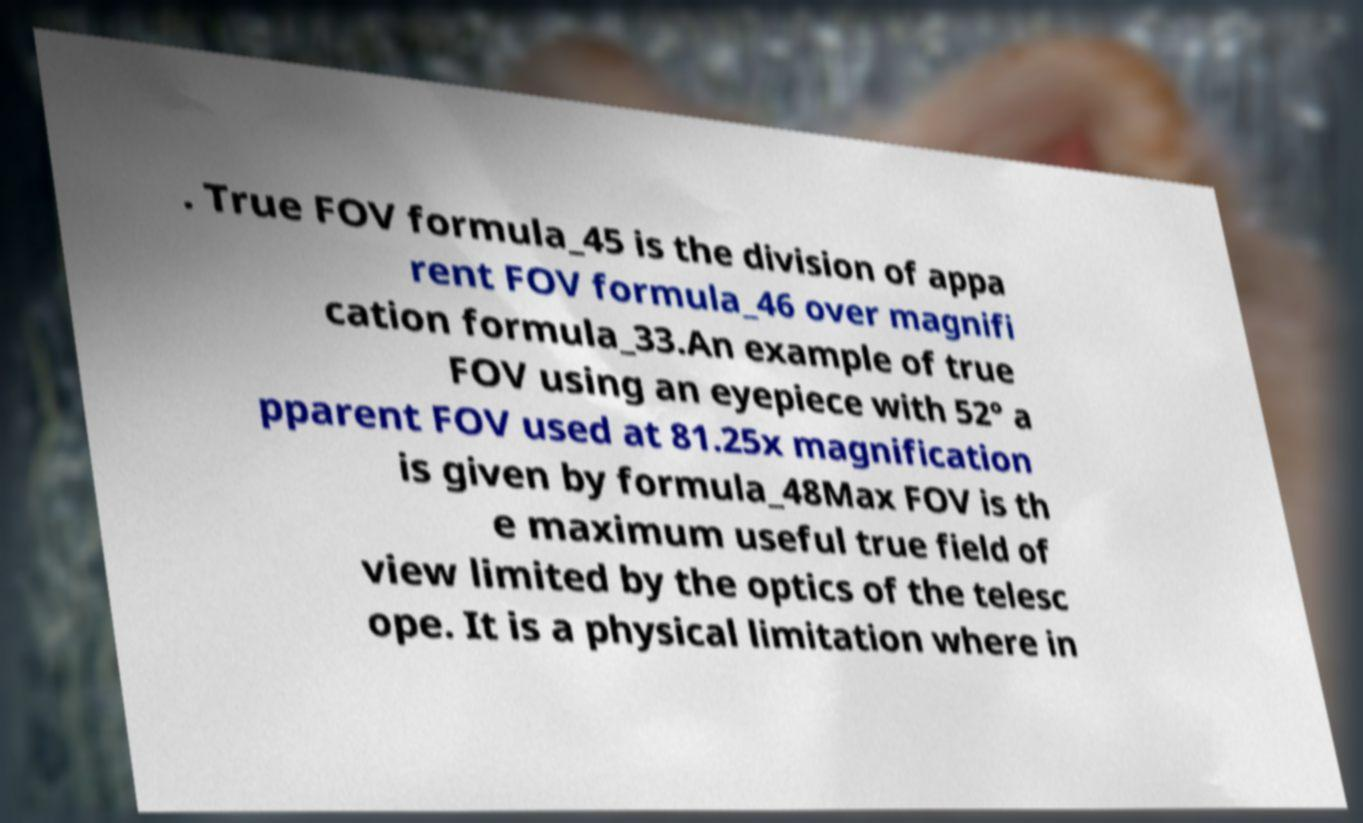I need the written content from this picture converted into text. Can you do that? . True FOV formula_45 is the division of appa rent FOV formula_46 over magnifi cation formula_33.An example of true FOV using an eyepiece with 52° a pparent FOV used at 81.25x magnification is given by formula_48Max FOV is th e maximum useful true field of view limited by the optics of the telesc ope. It is a physical limitation where in 